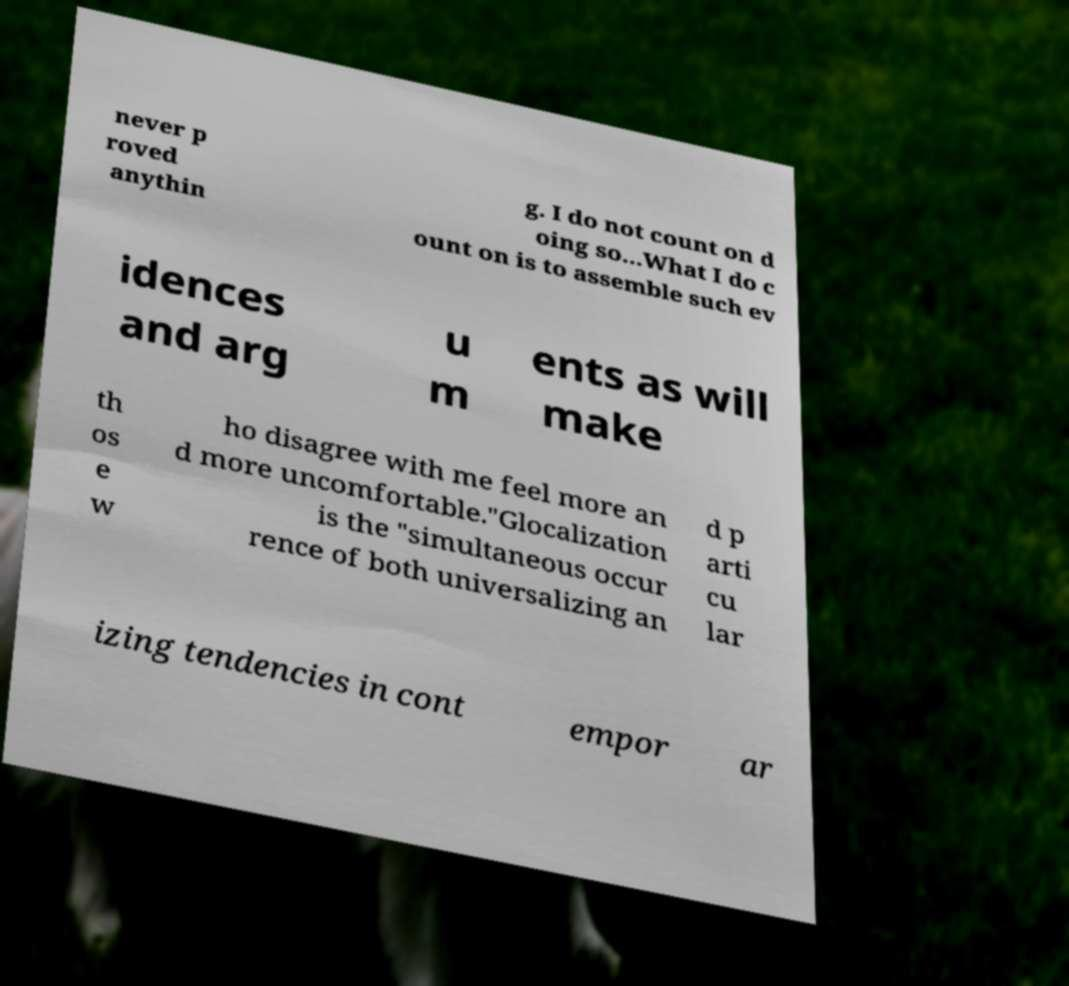Could you extract and type out the text from this image? never p roved anythin g. I do not count on d oing so...What I do c ount on is to assemble such ev idences and arg u m ents as will make th os e w ho disagree with me feel more an d more uncomfortable."Glocalization is the "simultaneous occur rence of both universalizing an d p arti cu lar izing tendencies in cont empor ar 